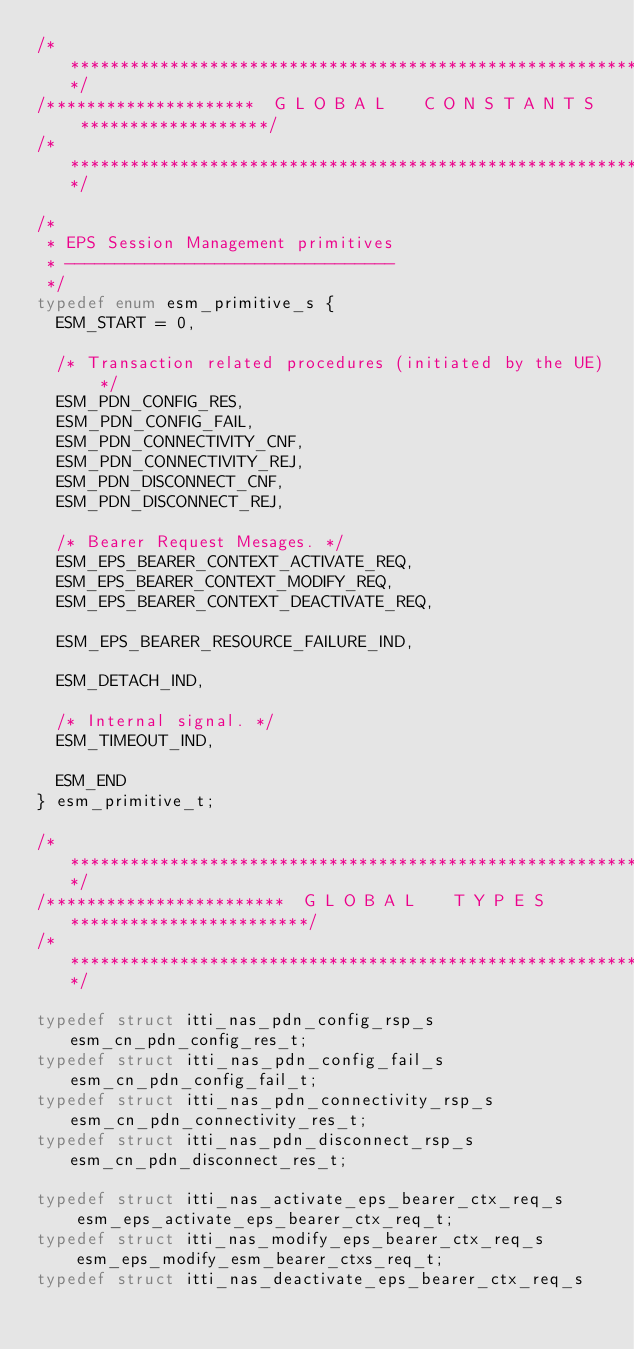<code> <loc_0><loc_0><loc_500><loc_500><_C_>/****************************************************************************/
/*********************  G L O B A L    C O N S T A N T S  *******************/
/****************************************************************************/

/*
 * EPS Session Management primitives
 * ---------------------------------
 */
typedef enum esm_primitive_s {
  ESM_START = 0,

  /* Transaction related procedures (initiated by the UE) */
  ESM_PDN_CONFIG_RES,
  ESM_PDN_CONFIG_FAIL,
  ESM_PDN_CONNECTIVITY_CNF,
  ESM_PDN_CONNECTIVITY_REJ,
  ESM_PDN_DISCONNECT_CNF,
  ESM_PDN_DISCONNECT_REJ,

  /* Bearer Request Mesages. */
  ESM_EPS_BEARER_CONTEXT_ACTIVATE_REQ,
  ESM_EPS_BEARER_CONTEXT_MODIFY_REQ,
  ESM_EPS_BEARER_CONTEXT_DEACTIVATE_REQ,

  ESM_EPS_BEARER_RESOURCE_FAILURE_IND,

  ESM_DETACH_IND,

  /* Internal signal. */
  ESM_TIMEOUT_IND,

  ESM_END
} esm_primitive_t;

/****************************************************************************/
/************************  G L O B A L    T Y P E S  ************************/
/****************************************************************************/

typedef struct itti_nas_pdn_config_rsp_s esm_cn_pdn_config_res_t;
typedef struct itti_nas_pdn_config_fail_s esm_cn_pdn_config_fail_t;
typedef struct itti_nas_pdn_connectivity_rsp_s esm_cn_pdn_connectivity_res_t;
typedef struct itti_nas_pdn_disconnect_rsp_s esm_cn_pdn_disconnect_res_t;

typedef struct itti_nas_activate_eps_bearer_ctx_req_s
    esm_eps_activate_eps_bearer_ctx_req_t;
typedef struct itti_nas_modify_eps_bearer_ctx_req_s
    esm_eps_modify_esm_bearer_ctxs_req_t;
typedef struct itti_nas_deactivate_eps_bearer_ctx_req_s</code> 